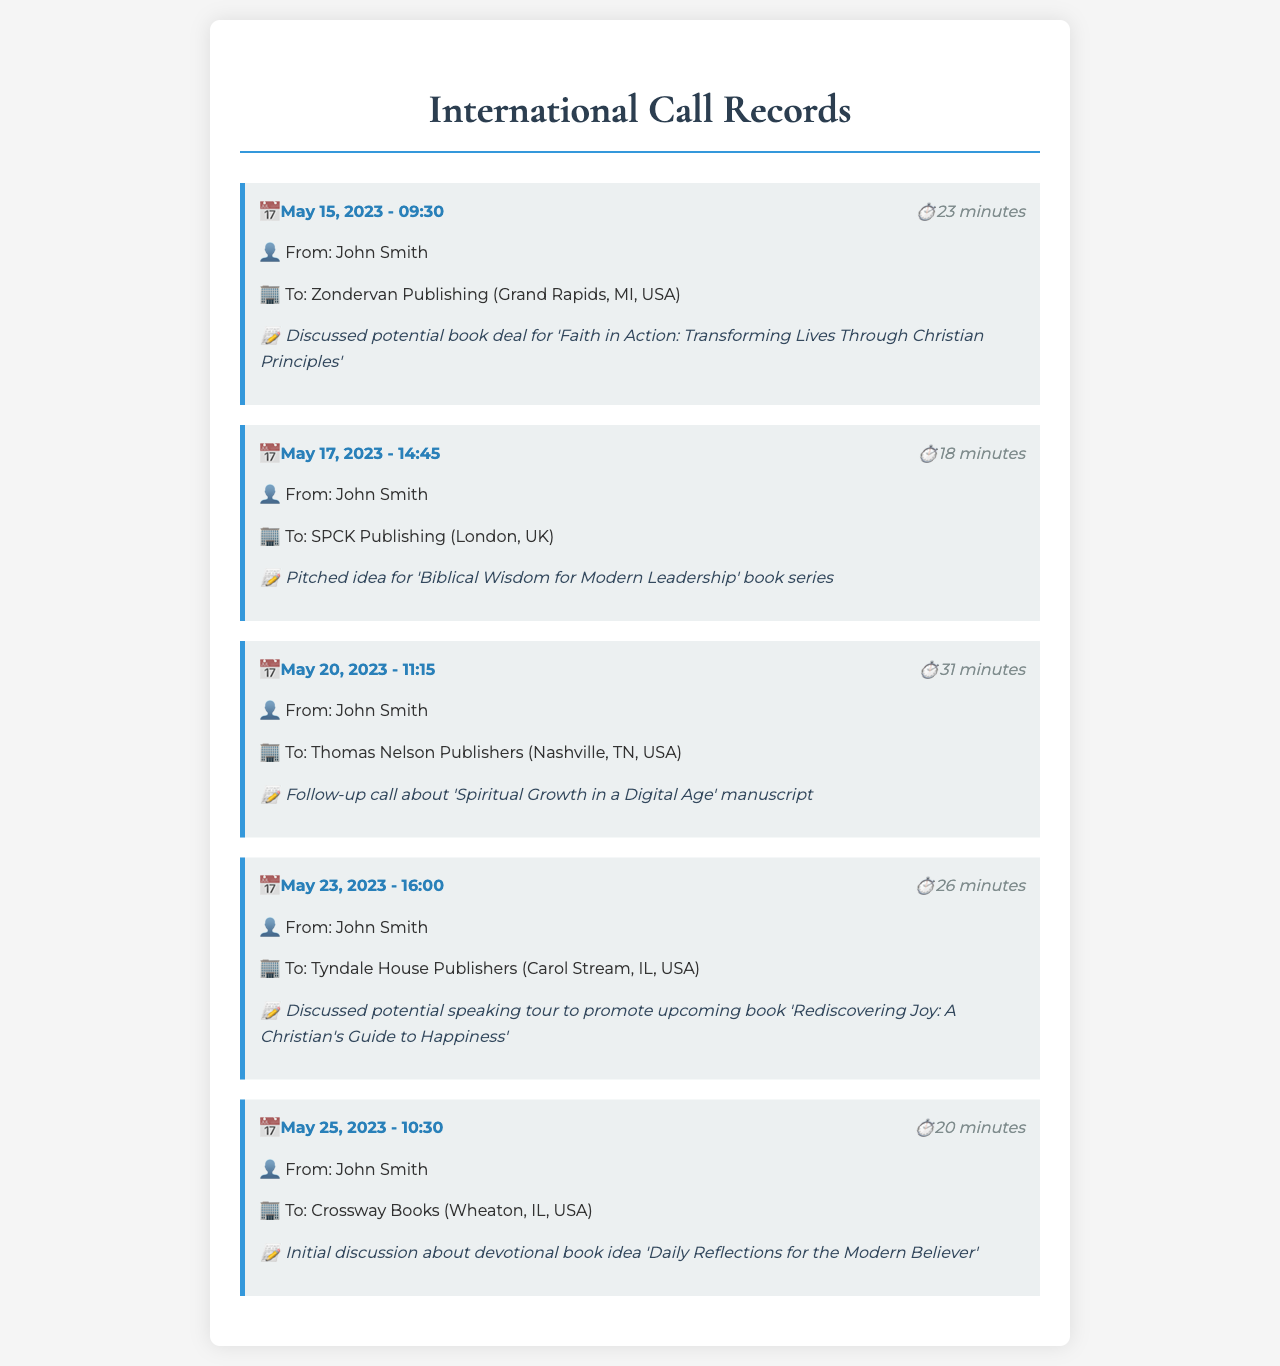What was the date of the first call? The first call was made on May 15, 2023, as listed in the call records.
Answer: May 15, 2023 How long was the call with SPCK Publishing? The duration of the call with SPCK Publishing was specifically noted in the records as 18 minutes.
Answer: 18 minutes Who did John Smith speak to on May 20, 2023? John Smith had a call with Thomas Nelson Publishers on May 20, 2023.
Answer: Thomas Nelson Publishers What is the title of the book discussed in the call on May 23, 2023? The book titled 'Rediscovering Joy: A Christian's Guide to Happiness' was discussed during that call.
Answer: Rediscovering Joy: A Christian's Guide to Happiness How many total calls are recorded in this document? The document contains a total of five individual call records.
Answer: 5 What was the purpose of the call with Crossway Books? The call with Crossway Books involved an initial discussion about a devotional book idea.
Answer: Initial discussion about devotional book idea Which publishing company was contacted for 'Faith in Action'? The call regarding 'Faith in Action' was made to Zondervan Publishing.
Answer: Zondervan Publishing What style of book series was pitched to SPCK Publishing? The pitched idea for SPCK Publishing was a book series focusing on 'Biblical Wisdom for Modern Leadership'.
Answer: Biblical Wisdom for Modern Leadership 